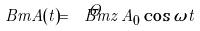Convert formula to latex. <formula><loc_0><loc_0><loc_500><loc_500>\ B m { A } ( t ) = \hat { \ B m z } \, A _ { 0 } \cos \omega t</formula> 